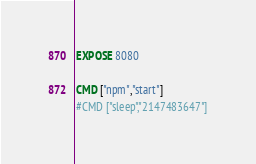<code> <loc_0><loc_0><loc_500><loc_500><_Dockerfile_>EXPOSE 8080

CMD ["npm","start"]
#CMD ["sleep","2147483647"]
</code> 